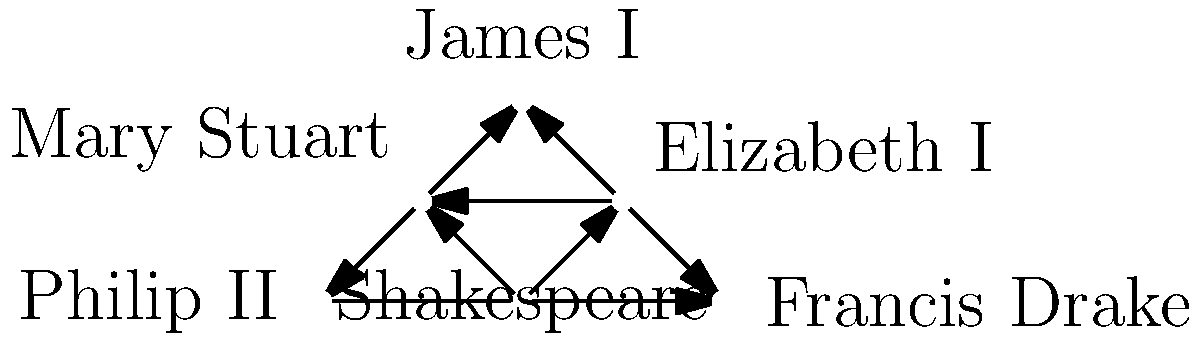In the social network diagram depicting relationships between historical figures, which individual serves as the central node connecting the most characters, potentially serving as a pivotal figure in a historical play? To determine the central node in this social network diagram, we need to analyze the connections between the historical figures:

1. Shakespeare: Connected to Elizabeth I and Mary Stuart (2 connections)
2. Elizabeth I: Connected to Shakespeare, Mary Stuart, James I, and Francis Drake (4 connections)
3. Mary Stuart: Connected to Shakespeare, Elizabeth I, James I, and Philip II (4 connections)
4. James I: Connected to Elizabeth I and Mary Stuart (2 connections)
5. Philip II: Connected to Mary Stuart and Francis Drake (2 connections)
6. Francis Drake: Connected to Elizabeth I and Philip II (2 connections)

From this analysis, we can see that Elizabeth I and Mary Stuart both have the highest number of connections (4 each). However, Elizabeth I's connections span a wider range of historical figures, including both English and non-English characters. This makes her a more central figure in terms of connecting different aspects of the historical narrative.

As a playwright using historical events as a basis for critically acclaimed plays, Elizabeth I would serve as an excellent central character. Her reign was a pivotal period in English history, and her connections to other important figures of the time (such as Shakespeare, Mary Stuart, James I, and Francis Drake) would allow for a rich, interconnected narrative exploring various aspects of the Elizabethan era.
Answer: Elizabeth I 